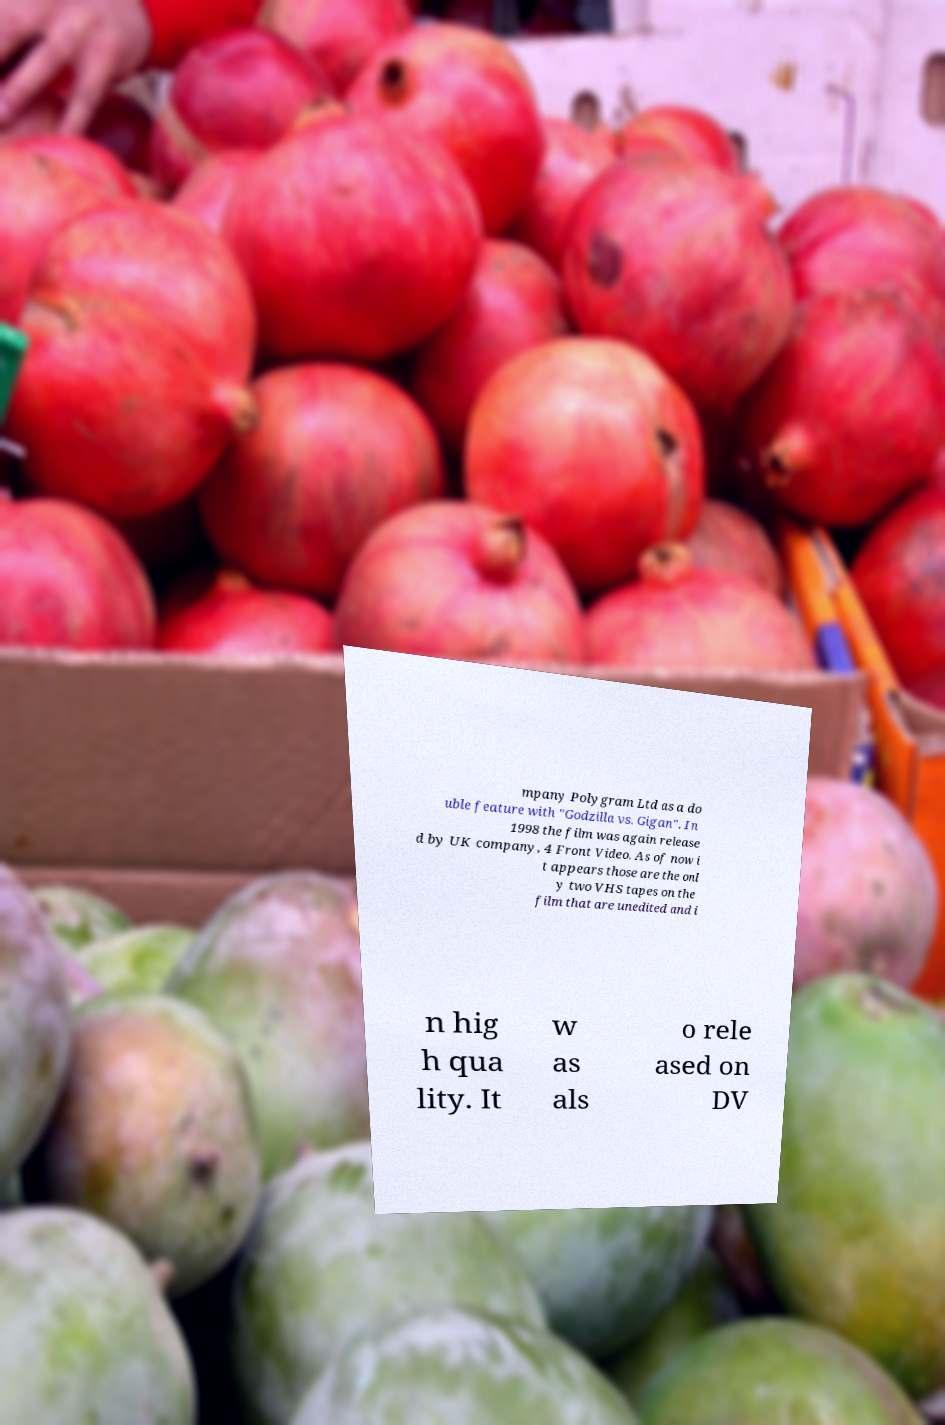For documentation purposes, I need the text within this image transcribed. Could you provide that? mpany Polygram Ltd as a do uble feature with "Godzilla vs. Gigan". In 1998 the film was again release d by UK company, 4 Front Video. As of now i t appears those are the onl y two VHS tapes on the film that are unedited and i n hig h qua lity. It w as als o rele ased on DV 